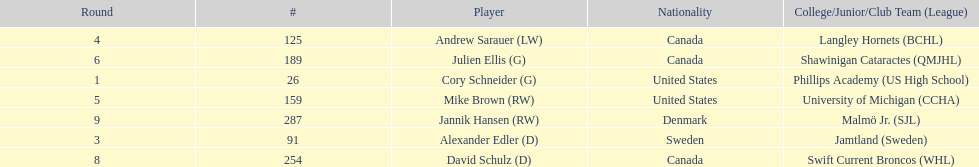How many players were from the united states? 2. 